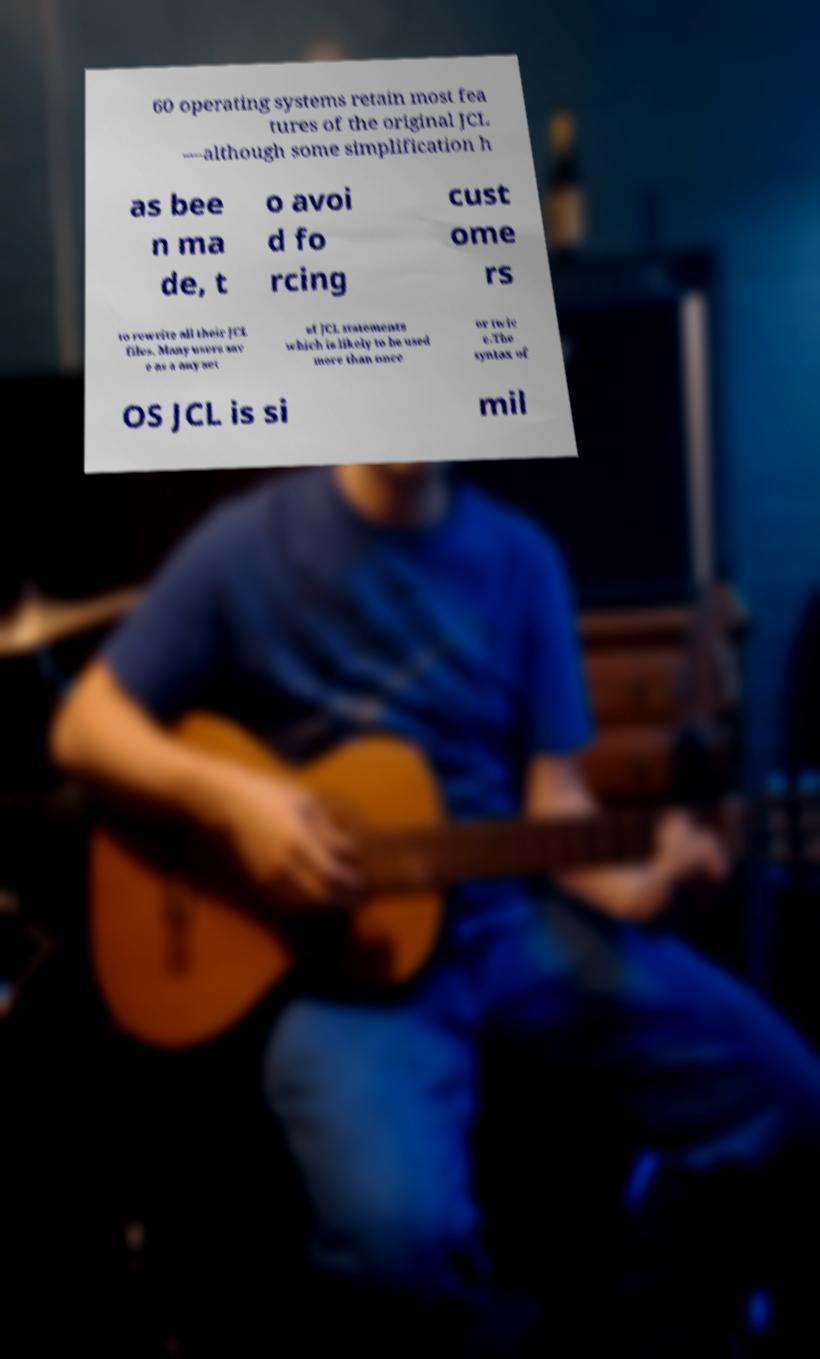For documentation purposes, I need the text within this image transcribed. Could you provide that? 60 operating systems retain most fea tures of the original JCL —although some simplification h as bee n ma de, t o avoi d fo rcing cust ome rs to rewrite all their JCL files. Many users sav e as a any set of JCL statements which is likely to be used more than once or twic e.The syntax of OS JCL is si mil 